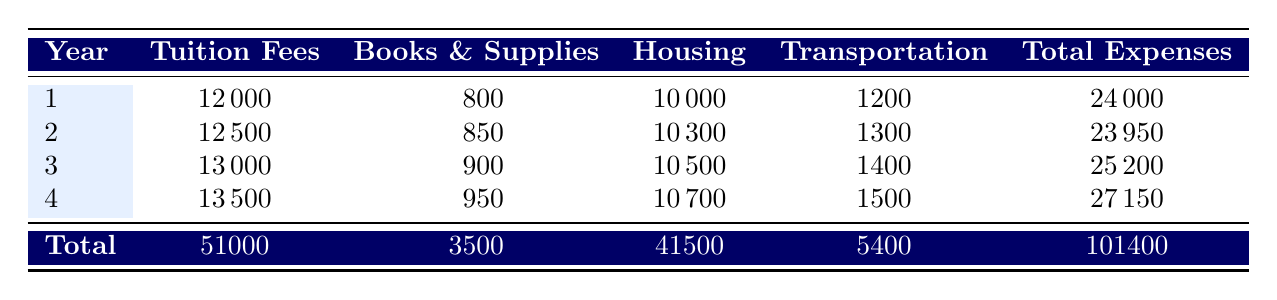What are the total tuition fees over four years? The total tuition fees are provided in the last row of the table, specifically under "Total Tuition Fees," which states 51000.
Answer: 51000 Which year had the highest total expenses? By comparing the "Total Expenses" column for each year, the highest amount is found in year 4, which is 27150.
Answer: Year 4 What was the total spending on housing over the four years? The total housing cost is listed in the last row under "Total Housing," which equals 41500.
Answer: 41500 What was the increase in tuition fees from year 1 to year 3? The tuition fee in year 1 is 12000, and in year 3 it is 13000. The difference is 13000 - 12000 = 1000.
Answer: 1000 Did the transportation expenses increase every year? Looking at the "Transportation" column, the amounts are 1200, 1300, 1400, and 1500, which shows a consistent increase each year.
Answer: Yes What was the average cost of books and supplies per year? The total for "Books & Supplies" is 3500, and there are 4 years. The average is calculated as 3500 / 4 = 875.
Answer: 875 In which year were housing costs the lowest? Reviewing the "Housing" column, year 1 has the lowest cost at 10000 compared to other years.
Answer: Year 1 What is the total amount spent on transportation across the four years? The total for "Transportation" expenses is included in the last row of the table, being 5400.
Answer: 5400 How much did the total expenses increase from year 1 to year 4? The total expenses for year 1 are 24000 and for year 4 are 27150. The increase is 27150 - 24000 = 3150.
Answer: 3150 